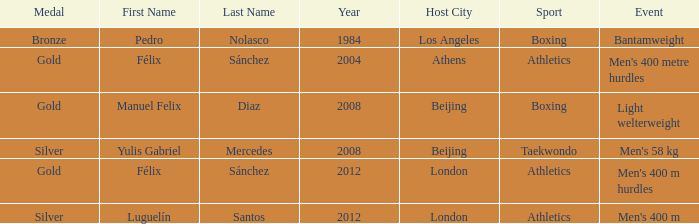Which medal was associated with félix sánchez during the 2012 london games? Gold. 